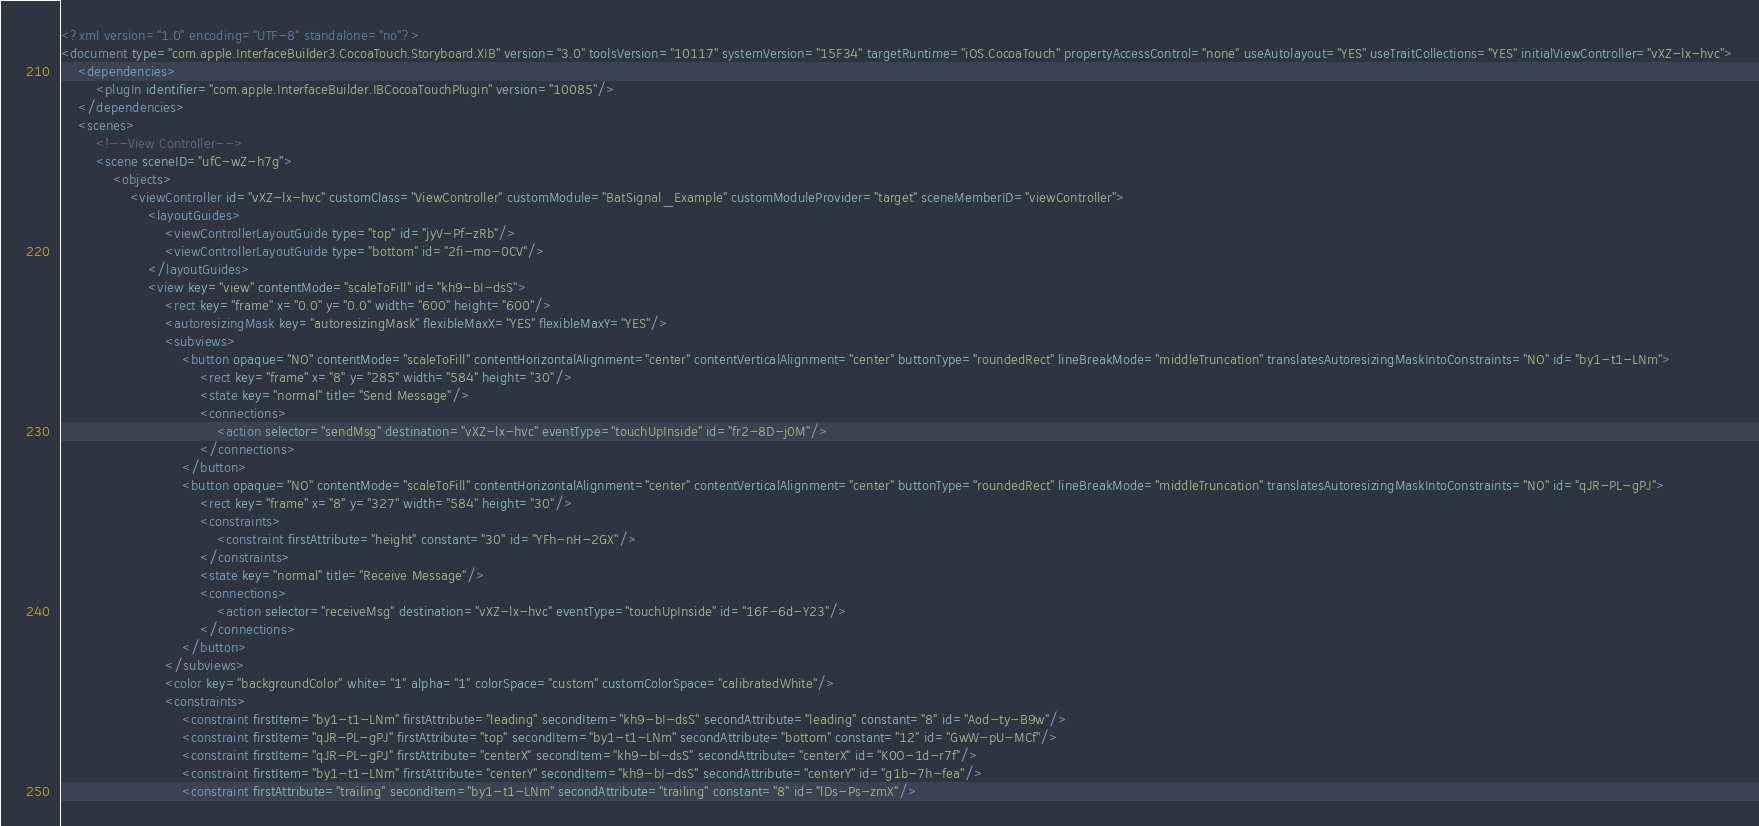Convert code to text. <code><loc_0><loc_0><loc_500><loc_500><_XML_><?xml version="1.0" encoding="UTF-8" standalone="no"?>
<document type="com.apple.InterfaceBuilder3.CocoaTouch.Storyboard.XIB" version="3.0" toolsVersion="10117" systemVersion="15F34" targetRuntime="iOS.CocoaTouch" propertyAccessControl="none" useAutolayout="YES" useTraitCollections="YES" initialViewController="vXZ-lx-hvc">
    <dependencies>
        <plugIn identifier="com.apple.InterfaceBuilder.IBCocoaTouchPlugin" version="10085"/>
    </dependencies>
    <scenes>
        <!--View Controller-->
        <scene sceneID="ufC-wZ-h7g">
            <objects>
                <viewController id="vXZ-lx-hvc" customClass="ViewController" customModule="BatSignal_Example" customModuleProvider="target" sceneMemberID="viewController">
                    <layoutGuides>
                        <viewControllerLayoutGuide type="top" id="jyV-Pf-zRb"/>
                        <viewControllerLayoutGuide type="bottom" id="2fi-mo-0CV"/>
                    </layoutGuides>
                    <view key="view" contentMode="scaleToFill" id="kh9-bI-dsS">
                        <rect key="frame" x="0.0" y="0.0" width="600" height="600"/>
                        <autoresizingMask key="autoresizingMask" flexibleMaxX="YES" flexibleMaxY="YES"/>
                        <subviews>
                            <button opaque="NO" contentMode="scaleToFill" contentHorizontalAlignment="center" contentVerticalAlignment="center" buttonType="roundedRect" lineBreakMode="middleTruncation" translatesAutoresizingMaskIntoConstraints="NO" id="by1-t1-LNm">
                                <rect key="frame" x="8" y="285" width="584" height="30"/>
                                <state key="normal" title="Send Message"/>
                                <connections>
                                    <action selector="sendMsg" destination="vXZ-lx-hvc" eventType="touchUpInside" id="fr2-8D-j0M"/>
                                </connections>
                            </button>
                            <button opaque="NO" contentMode="scaleToFill" contentHorizontalAlignment="center" contentVerticalAlignment="center" buttonType="roundedRect" lineBreakMode="middleTruncation" translatesAutoresizingMaskIntoConstraints="NO" id="qJR-PL-gPJ">
                                <rect key="frame" x="8" y="327" width="584" height="30"/>
                                <constraints>
                                    <constraint firstAttribute="height" constant="30" id="YFh-nH-2GX"/>
                                </constraints>
                                <state key="normal" title="Receive Message"/>
                                <connections>
                                    <action selector="receiveMsg" destination="vXZ-lx-hvc" eventType="touchUpInside" id="16F-6d-Y23"/>
                                </connections>
                            </button>
                        </subviews>
                        <color key="backgroundColor" white="1" alpha="1" colorSpace="custom" customColorSpace="calibratedWhite"/>
                        <constraints>
                            <constraint firstItem="by1-t1-LNm" firstAttribute="leading" secondItem="kh9-bI-dsS" secondAttribute="leading" constant="8" id="Aod-ty-B9w"/>
                            <constraint firstItem="qJR-PL-gPJ" firstAttribute="top" secondItem="by1-t1-LNm" secondAttribute="bottom" constant="12" id="GwW-pU-MCf"/>
                            <constraint firstItem="qJR-PL-gPJ" firstAttribute="centerX" secondItem="kh9-bI-dsS" secondAttribute="centerX" id="K0O-1d-r7f"/>
                            <constraint firstItem="by1-t1-LNm" firstAttribute="centerY" secondItem="kh9-bI-dsS" secondAttribute="centerY" id="g1b-7h-fea"/>
                            <constraint firstAttribute="trailing" secondItem="by1-t1-LNm" secondAttribute="trailing" constant="8" id="lDs-Ps-zmX"/></code> 